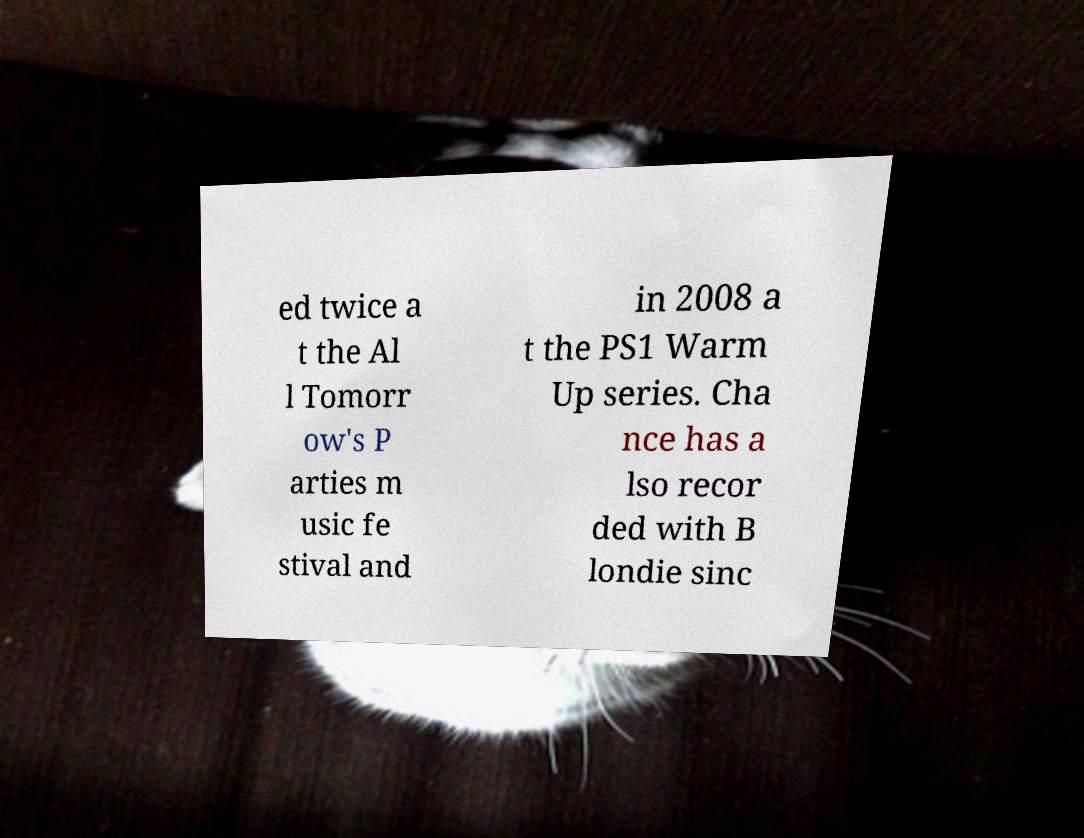I need the written content from this picture converted into text. Can you do that? ed twice a t the Al l Tomorr ow's P arties m usic fe stival and in 2008 a t the PS1 Warm Up series. Cha nce has a lso recor ded with B londie sinc 